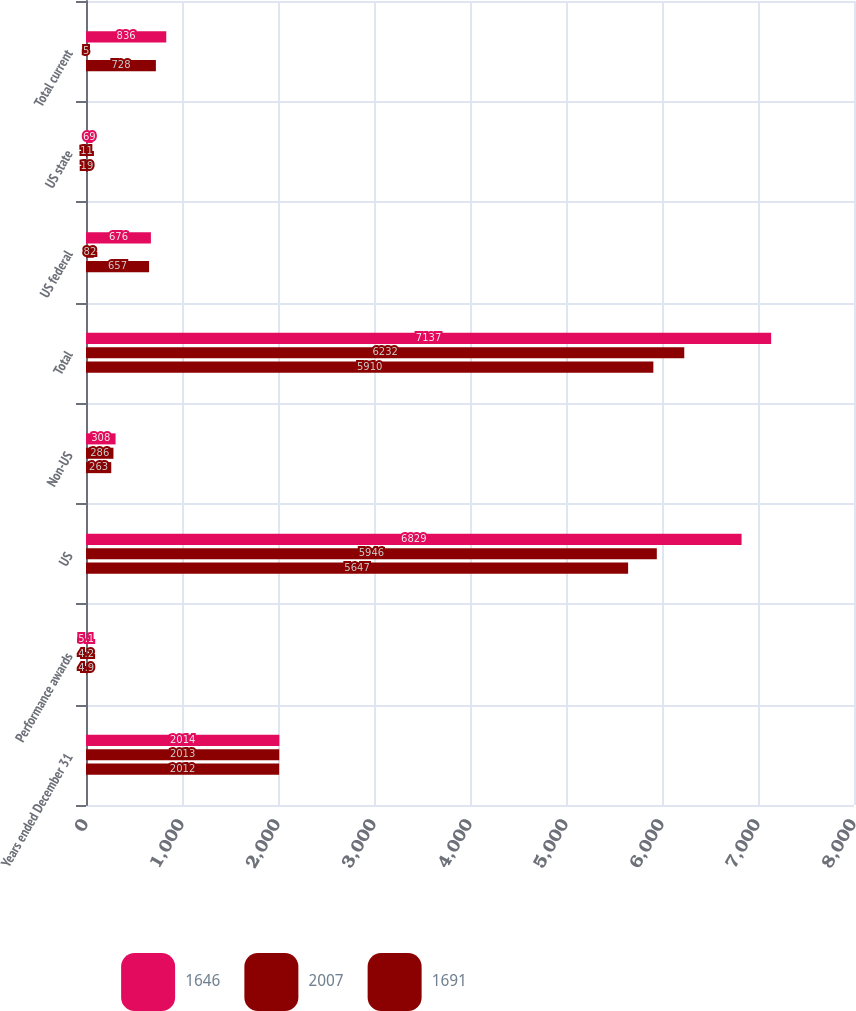<chart> <loc_0><loc_0><loc_500><loc_500><stacked_bar_chart><ecel><fcel>Years ended December 31<fcel>Performance awards<fcel>US<fcel>Non-US<fcel>Total<fcel>US federal<fcel>US state<fcel>Total current<nl><fcel>1646<fcel>2014<fcel>5.1<fcel>6829<fcel>308<fcel>7137<fcel>676<fcel>69<fcel>836<nl><fcel>2007<fcel>2013<fcel>4.2<fcel>5946<fcel>286<fcel>6232<fcel>82<fcel>11<fcel>5<nl><fcel>1691<fcel>2012<fcel>4.9<fcel>5647<fcel>263<fcel>5910<fcel>657<fcel>19<fcel>728<nl></chart> 